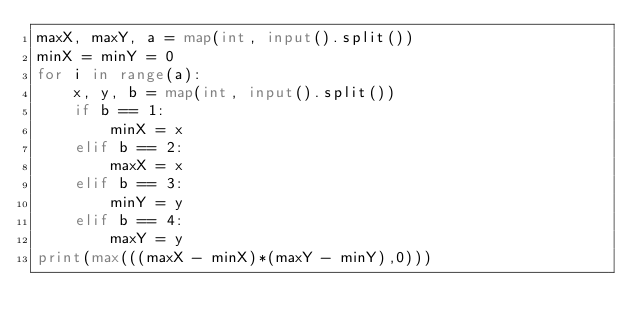Convert code to text. <code><loc_0><loc_0><loc_500><loc_500><_Python_>maxX, maxY, a = map(int, input().split())
minX = minY = 0
for i in range(a):
    x, y, b = map(int, input().split())
    if b == 1:
        minX = x
    elif b == 2:
        maxX = x
    elif b == 3:
        minY = y
    elif b == 4:
        maxY = y
print(max(((maxX - minX)*(maxY - minY),0)))
</code> 